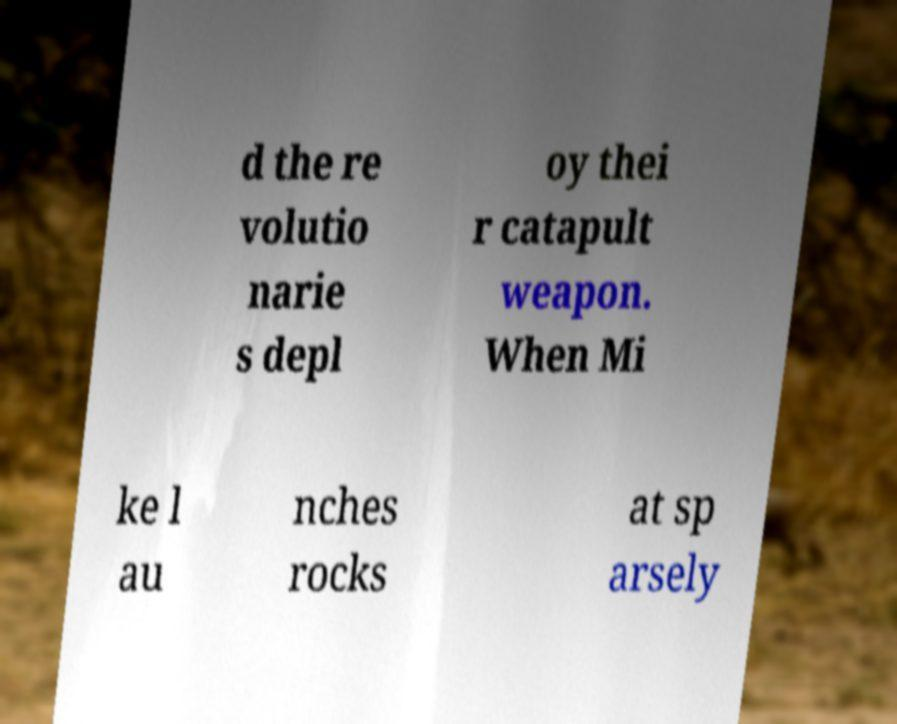Can you read and provide the text displayed in the image?This photo seems to have some interesting text. Can you extract and type it out for me? d the re volutio narie s depl oy thei r catapult weapon. When Mi ke l au nches rocks at sp arsely 